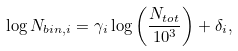Convert formula to latex. <formula><loc_0><loc_0><loc_500><loc_500>\log N _ { b i n , i } = { \gamma _ { i } } \log \left ( \frac { N _ { t o t } } { 1 0 ^ { 3 } } \right ) + \delta _ { i } ,</formula> 